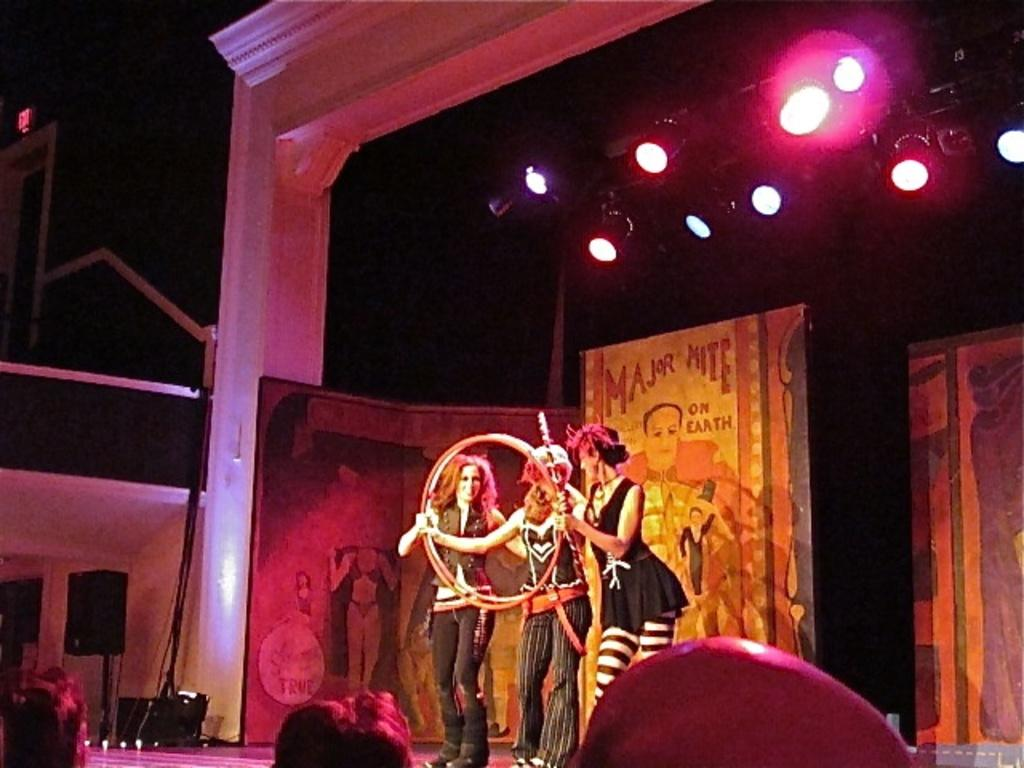What type of lights are present in the image? There are focusing lights in the image. What are the three people doing in the image? They are holding rings in the image. What device is used for amplifying sound in the image? There is a speaker in the image. What can be seen in the background of the image? There are hoardings in the background of the image. What type of bell can be heard ringing in the image? There is no bell present in the image, and therefore no sound can be heard. What kind of bait is being used by the people holding rings in the image? The people holding rings in the image are not using any bait; they are simply holding rings. 